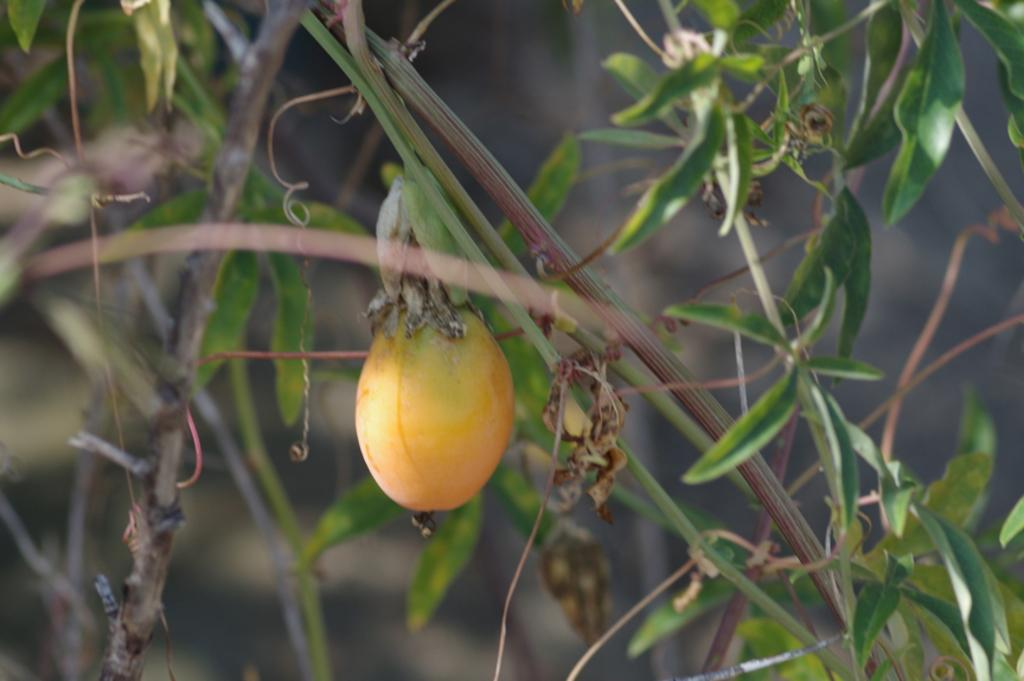What type of plant is in the center of the image? There is a tree in the center of the image. What can be found on the tree in the image? There is a fruit on the tree in the image. How many cows are standing under the tree in the image? There are no cows present in the image; it only features a tree with fruit on it. What type of pump is visible near the tree in the image? There is no pump present in the image; it only features a tree with fruit on it. 